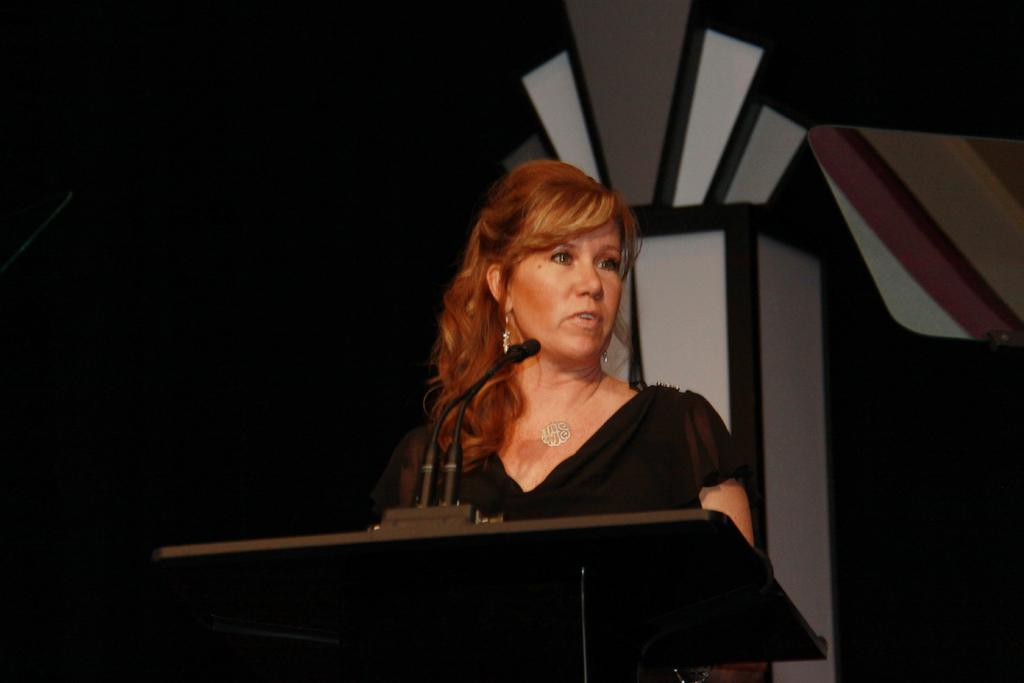Who is the main subject in the picture? There is a woman in the center of the picture. What is the woman wearing? The woman is wearing a black dress. What is the woman doing in the image? The woman is standing in front of a podium and speaking into microphones. What can be seen in the background of the image? There is a pillar in the background of the image, and the background is dark. What type of donkey can be seen in the image? There is no donkey present in the image. What selection of items is the woman offering to the audience in the image? The image does not show the woman offering any items to the audience. 